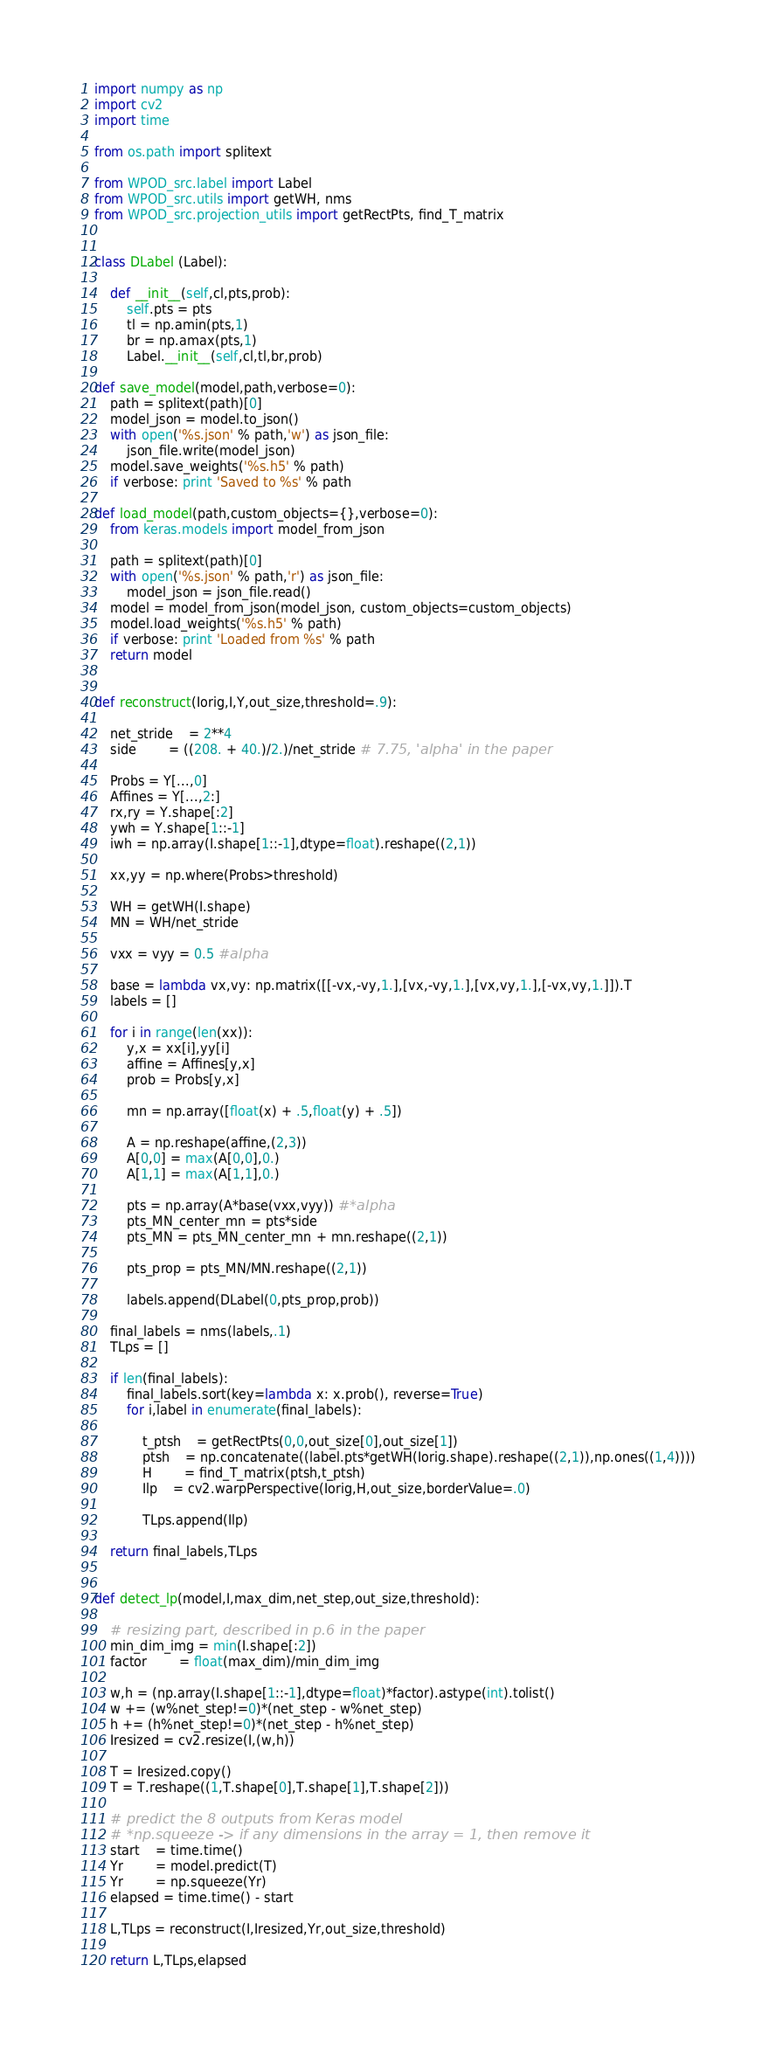Convert code to text. <code><loc_0><loc_0><loc_500><loc_500><_Python_>
import numpy as np
import cv2
import time

from os.path import splitext

from WPOD_src.label import Label
from WPOD_src.utils import getWH, nms
from WPOD_src.projection_utils import getRectPts, find_T_matrix


class DLabel (Label):

	def __init__(self,cl,pts,prob):
		self.pts = pts
		tl = np.amin(pts,1)
		br = np.amax(pts,1)
		Label.__init__(self,cl,tl,br,prob)

def save_model(model,path,verbose=0):
	path = splitext(path)[0]
	model_json = model.to_json()
	with open('%s.json' % path,'w') as json_file:
		json_file.write(model_json)
	model.save_weights('%s.h5' % path)
	if verbose: print 'Saved to %s' % path

def load_model(path,custom_objects={},verbose=0):
	from keras.models import model_from_json

	path = splitext(path)[0]
	with open('%s.json' % path,'r') as json_file:
		model_json = json_file.read()
	model = model_from_json(model_json, custom_objects=custom_objects)
	model.load_weights('%s.h5' % path)
	if verbose: print 'Loaded from %s' % path
	return model


def reconstruct(Iorig,I,Y,out_size,threshold=.9):

	net_stride 	= 2**4
	side 		= ((208. + 40.)/2.)/net_stride # 7.75, 'alpha' in the paper

	Probs = Y[...,0]
	Affines = Y[...,2:]
	rx,ry = Y.shape[:2]
	ywh = Y.shape[1::-1]
	iwh = np.array(I.shape[1::-1],dtype=float).reshape((2,1))

	xx,yy = np.where(Probs>threshold)

	WH = getWH(I.shape)
	MN = WH/net_stride

	vxx = vyy = 0.5 #alpha

	base = lambda vx,vy: np.matrix([[-vx,-vy,1.],[vx,-vy,1.],[vx,vy,1.],[-vx,vy,1.]]).T
	labels = []

	for i in range(len(xx)):
		y,x = xx[i],yy[i]
		affine = Affines[y,x]
		prob = Probs[y,x]

		mn = np.array([float(x) + .5,float(y) + .5])

		A = np.reshape(affine,(2,3))
		A[0,0] = max(A[0,0],0.)
		A[1,1] = max(A[1,1],0.)

		pts = np.array(A*base(vxx,vyy)) #*alpha
		pts_MN_center_mn = pts*side
		pts_MN = pts_MN_center_mn + mn.reshape((2,1))

		pts_prop = pts_MN/MN.reshape((2,1))

		labels.append(DLabel(0,pts_prop,prob))

	final_labels = nms(labels,.1)
	TLps = []

	if len(final_labels):
		final_labels.sort(key=lambda x: x.prob(), reverse=True)
		for i,label in enumerate(final_labels):

			t_ptsh 	= getRectPts(0,0,out_size[0],out_size[1])
			ptsh 	= np.concatenate((label.pts*getWH(Iorig.shape).reshape((2,1)),np.ones((1,4))))
			H 		= find_T_matrix(ptsh,t_ptsh)
			Ilp 	= cv2.warpPerspective(Iorig,H,out_size,borderValue=.0)

			TLps.append(Ilp)

	return final_labels,TLps
	

def detect_lp(model,I,max_dim,net_step,out_size,threshold):

	# resizing part, described in p.6 in the paper
	min_dim_img = min(I.shape[:2])
	factor 		= float(max_dim)/min_dim_img

	w,h = (np.array(I.shape[1::-1],dtype=float)*factor).astype(int).tolist()
	w += (w%net_step!=0)*(net_step - w%net_step)
	h += (h%net_step!=0)*(net_step - h%net_step)
	Iresized = cv2.resize(I,(w,h))

	T = Iresized.copy()
	T = T.reshape((1,T.shape[0],T.shape[1],T.shape[2]))

	# predict the 8 outputs from Keras model
	# *np.squeeze -> if any dimensions in the array = 1, then remove it
	start 	= time.time()
	Yr 		= model.predict(T)
	Yr 		= np.squeeze(Yr)
	elapsed = time.time() - start

	L,TLps = reconstruct(I,Iresized,Yr,out_size,threshold)

	return L,TLps,elapsed</code> 